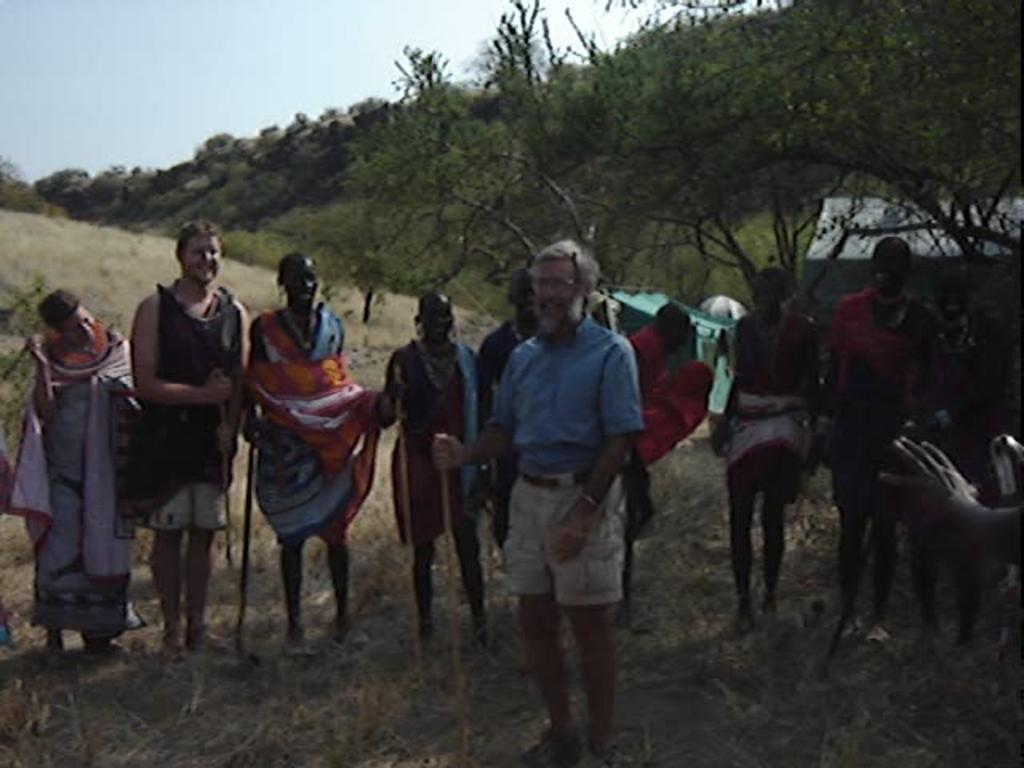What is the main subject of the image? The main subject of the image is many persons standing on the grass in the center of the image. What can be seen in the background of the image? In the background of the image, there are trees, a house, plants, grass, and the sky. How many elements are present in the background of the image? There are five elements present in the background: trees, a house, plants, grass, and the sky. What type of angle is being used to view the tail of the wine in the image? There is no angle, tail, or wine present in the image. 